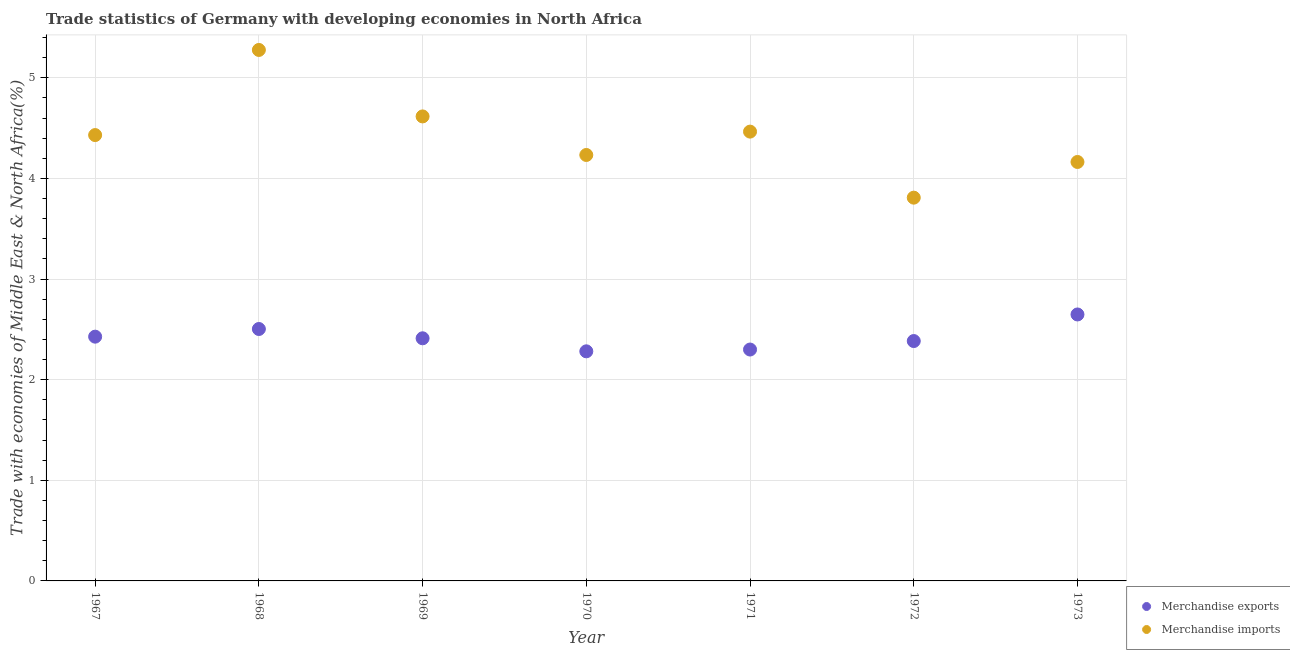Is the number of dotlines equal to the number of legend labels?
Make the answer very short. Yes. What is the merchandise imports in 1971?
Offer a terse response. 4.46. Across all years, what is the maximum merchandise exports?
Offer a very short reply. 2.65. Across all years, what is the minimum merchandise exports?
Keep it short and to the point. 2.28. In which year was the merchandise imports maximum?
Offer a very short reply. 1968. In which year was the merchandise imports minimum?
Ensure brevity in your answer.  1972. What is the total merchandise exports in the graph?
Keep it short and to the point. 16.95. What is the difference between the merchandise imports in 1968 and that in 1970?
Provide a short and direct response. 1.04. What is the difference between the merchandise exports in 1972 and the merchandise imports in 1971?
Your answer should be very brief. -2.08. What is the average merchandise exports per year?
Provide a succinct answer. 2.42. In the year 1967, what is the difference between the merchandise imports and merchandise exports?
Your answer should be very brief. 2. What is the ratio of the merchandise exports in 1968 to that in 1969?
Keep it short and to the point. 1.04. Is the difference between the merchandise imports in 1970 and 1972 greater than the difference between the merchandise exports in 1970 and 1972?
Ensure brevity in your answer.  Yes. What is the difference between the highest and the second highest merchandise imports?
Your answer should be very brief. 0.66. What is the difference between the highest and the lowest merchandise imports?
Offer a very short reply. 1.47. Does the merchandise exports monotonically increase over the years?
Keep it short and to the point. No. Is the merchandise imports strictly greater than the merchandise exports over the years?
Make the answer very short. Yes. How many dotlines are there?
Provide a succinct answer. 2. Are the values on the major ticks of Y-axis written in scientific E-notation?
Your answer should be very brief. No. Does the graph contain grids?
Your answer should be very brief. Yes. How many legend labels are there?
Provide a short and direct response. 2. How are the legend labels stacked?
Provide a succinct answer. Vertical. What is the title of the graph?
Offer a terse response. Trade statistics of Germany with developing economies in North Africa. Does "Working only" appear as one of the legend labels in the graph?
Give a very brief answer. No. What is the label or title of the Y-axis?
Your answer should be very brief. Trade with economies of Middle East & North Africa(%). What is the Trade with economies of Middle East & North Africa(%) of Merchandise exports in 1967?
Offer a terse response. 2.43. What is the Trade with economies of Middle East & North Africa(%) in Merchandise imports in 1967?
Your answer should be very brief. 4.43. What is the Trade with economies of Middle East & North Africa(%) of Merchandise exports in 1968?
Give a very brief answer. 2.5. What is the Trade with economies of Middle East & North Africa(%) of Merchandise imports in 1968?
Make the answer very short. 5.28. What is the Trade with economies of Middle East & North Africa(%) of Merchandise exports in 1969?
Ensure brevity in your answer.  2.41. What is the Trade with economies of Middle East & North Africa(%) of Merchandise imports in 1969?
Your response must be concise. 4.62. What is the Trade with economies of Middle East & North Africa(%) of Merchandise exports in 1970?
Provide a succinct answer. 2.28. What is the Trade with economies of Middle East & North Africa(%) in Merchandise imports in 1970?
Keep it short and to the point. 4.23. What is the Trade with economies of Middle East & North Africa(%) in Merchandise exports in 1971?
Offer a very short reply. 2.3. What is the Trade with economies of Middle East & North Africa(%) of Merchandise imports in 1971?
Make the answer very short. 4.46. What is the Trade with economies of Middle East & North Africa(%) in Merchandise exports in 1972?
Your answer should be compact. 2.38. What is the Trade with economies of Middle East & North Africa(%) in Merchandise imports in 1972?
Offer a terse response. 3.81. What is the Trade with economies of Middle East & North Africa(%) of Merchandise exports in 1973?
Ensure brevity in your answer.  2.65. What is the Trade with economies of Middle East & North Africa(%) of Merchandise imports in 1973?
Provide a short and direct response. 4.16. Across all years, what is the maximum Trade with economies of Middle East & North Africa(%) of Merchandise exports?
Offer a terse response. 2.65. Across all years, what is the maximum Trade with economies of Middle East & North Africa(%) of Merchandise imports?
Your response must be concise. 5.28. Across all years, what is the minimum Trade with economies of Middle East & North Africa(%) of Merchandise exports?
Give a very brief answer. 2.28. Across all years, what is the minimum Trade with economies of Middle East & North Africa(%) in Merchandise imports?
Your answer should be compact. 3.81. What is the total Trade with economies of Middle East & North Africa(%) in Merchandise exports in the graph?
Ensure brevity in your answer.  16.95. What is the total Trade with economies of Middle East & North Africa(%) of Merchandise imports in the graph?
Provide a succinct answer. 30.99. What is the difference between the Trade with economies of Middle East & North Africa(%) of Merchandise exports in 1967 and that in 1968?
Your response must be concise. -0.08. What is the difference between the Trade with economies of Middle East & North Africa(%) in Merchandise imports in 1967 and that in 1968?
Your answer should be very brief. -0.85. What is the difference between the Trade with economies of Middle East & North Africa(%) of Merchandise exports in 1967 and that in 1969?
Make the answer very short. 0.02. What is the difference between the Trade with economies of Middle East & North Africa(%) in Merchandise imports in 1967 and that in 1969?
Give a very brief answer. -0.19. What is the difference between the Trade with economies of Middle East & North Africa(%) in Merchandise exports in 1967 and that in 1970?
Give a very brief answer. 0.15. What is the difference between the Trade with economies of Middle East & North Africa(%) in Merchandise imports in 1967 and that in 1970?
Keep it short and to the point. 0.2. What is the difference between the Trade with economies of Middle East & North Africa(%) in Merchandise exports in 1967 and that in 1971?
Offer a terse response. 0.13. What is the difference between the Trade with economies of Middle East & North Africa(%) in Merchandise imports in 1967 and that in 1971?
Offer a terse response. -0.03. What is the difference between the Trade with economies of Middle East & North Africa(%) of Merchandise exports in 1967 and that in 1972?
Your response must be concise. 0.04. What is the difference between the Trade with economies of Middle East & North Africa(%) in Merchandise imports in 1967 and that in 1972?
Make the answer very short. 0.62. What is the difference between the Trade with economies of Middle East & North Africa(%) in Merchandise exports in 1967 and that in 1973?
Provide a short and direct response. -0.22. What is the difference between the Trade with economies of Middle East & North Africa(%) of Merchandise imports in 1967 and that in 1973?
Provide a succinct answer. 0.27. What is the difference between the Trade with economies of Middle East & North Africa(%) of Merchandise exports in 1968 and that in 1969?
Provide a succinct answer. 0.09. What is the difference between the Trade with economies of Middle East & North Africa(%) in Merchandise imports in 1968 and that in 1969?
Provide a succinct answer. 0.66. What is the difference between the Trade with economies of Middle East & North Africa(%) of Merchandise exports in 1968 and that in 1970?
Provide a succinct answer. 0.22. What is the difference between the Trade with economies of Middle East & North Africa(%) in Merchandise imports in 1968 and that in 1970?
Provide a short and direct response. 1.04. What is the difference between the Trade with economies of Middle East & North Africa(%) in Merchandise exports in 1968 and that in 1971?
Make the answer very short. 0.2. What is the difference between the Trade with economies of Middle East & North Africa(%) of Merchandise imports in 1968 and that in 1971?
Offer a terse response. 0.81. What is the difference between the Trade with economies of Middle East & North Africa(%) in Merchandise exports in 1968 and that in 1972?
Provide a succinct answer. 0.12. What is the difference between the Trade with economies of Middle East & North Africa(%) of Merchandise imports in 1968 and that in 1972?
Your answer should be compact. 1.47. What is the difference between the Trade with economies of Middle East & North Africa(%) of Merchandise exports in 1968 and that in 1973?
Keep it short and to the point. -0.14. What is the difference between the Trade with economies of Middle East & North Africa(%) in Merchandise imports in 1968 and that in 1973?
Ensure brevity in your answer.  1.11. What is the difference between the Trade with economies of Middle East & North Africa(%) of Merchandise exports in 1969 and that in 1970?
Keep it short and to the point. 0.13. What is the difference between the Trade with economies of Middle East & North Africa(%) in Merchandise imports in 1969 and that in 1970?
Give a very brief answer. 0.38. What is the difference between the Trade with economies of Middle East & North Africa(%) in Merchandise exports in 1969 and that in 1971?
Offer a very short reply. 0.11. What is the difference between the Trade with economies of Middle East & North Africa(%) in Merchandise imports in 1969 and that in 1971?
Provide a succinct answer. 0.15. What is the difference between the Trade with economies of Middle East & North Africa(%) of Merchandise exports in 1969 and that in 1972?
Offer a terse response. 0.03. What is the difference between the Trade with economies of Middle East & North Africa(%) of Merchandise imports in 1969 and that in 1972?
Give a very brief answer. 0.81. What is the difference between the Trade with economies of Middle East & North Africa(%) of Merchandise exports in 1969 and that in 1973?
Provide a succinct answer. -0.24. What is the difference between the Trade with economies of Middle East & North Africa(%) in Merchandise imports in 1969 and that in 1973?
Offer a very short reply. 0.45. What is the difference between the Trade with economies of Middle East & North Africa(%) in Merchandise exports in 1970 and that in 1971?
Your answer should be compact. -0.02. What is the difference between the Trade with economies of Middle East & North Africa(%) in Merchandise imports in 1970 and that in 1971?
Offer a terse response. -0.23. What is the difference between the Trade with economies of Middle East & North Africa(%) of Merchandise exports in 1970 and that in 1972?
Your answer should be very brief. -0.1. What is the difference between the Trade with economies of Middle East & North Africa(%) in Merchandise imports in 1970 and that in 1972?
Give a very brief answer. 0.42. What is the difference between the Trade with economies of Middle East & North Africa(%) in Merchandise exports in 1970 and that in 1973?
Make the answer very short. -0.37. What is the difference between the Trade with economies of Middle East & North Africa(%) of Merchandise imports in 1970 and that in 1973?
Provide a short and direct response. 0.07. What is the difference between the Trade with economies of Middle East & North Africa(%) of Merchandise exports in 1971 and that in 1972?
Offer a very short reply. -0.08. What is the difference between the Trade with economies of Middle East & North Africa(%) of Merchandise imports in 1971 and that in 1972?
Provide a short and direct response. 0.66. What is the difference between the Trade with economies of Middle East & North Africa(%) in Merchandise exports in 1971 and that in 1973?
Your answer should be very brief. -0.35. What is the difference between the Trade with economies of Middle East & North Africa(%) in Merchandise imports in 1971 and that in 1973?
Provide a short and direct response. 0.3. What is the difference between the Trade with economies of Middle East & North Africa(%) of Merchandise exports in 1972 and that in 1973?
Provide a succinct answer. -0.26. What is the difference between the Trade with economies of Middle East & North Africa(%) of Merchandise imports in 1972 and that in 1973?
Offer a very short reply. -0.35. What is the difference between the Trade with economies of Middle East & North Africa(%) in Merchandise exports in 1967 and the Trade with economies of Middle East & North Africa(%) in Merchandise imports in 1968?
Your answer should be very brief. -2.85. What is the difference between the Trade with economies of Middle East & North Africa(%) in Merchandise exports in 1967 and the Trade with economies of Middle East & North Africa(%) in Merchandise imports in 1969?
Your answer should be very brief. -2.19. What is the difference between the Trade with economies of Middle East & North Africa(%) of Merchandise exports in 1967 and the Trade with economies of Middle East & North Africa(%) of Merchandise imports in 1970?
Ensure brevity in your answer.  -1.81. What is the difference between the Trade with economies of Middle East & North Africa(%) of Merchandise exports in 1967 and the Trade with economies of Middle East & North Africa(%) of Merchandise imports in 1971?
Keep it short and to the point. -2.04. What is the difference between the Trade with economies of Middle East & North Africa(%) of Merchandise exports in 1967 and the Trade with economies of Middle East & North Africa(%) of Merchandise imports in 1972?
Your answer should be compact. -1.38. What is the difference between the Trade with economies of Middle East & North Africa(%) in Merchandise exports in 1967 and the Trade with economies of Middle East & North Africa(%) in Merchandise imports in 1973?
Your answer should be compact. -1.74. What is the difference between the Trade with economies of Middle East & North Africa(%) in Merchandise exports in 1968 and the Trade with economies of Middle East & North Africa(%) in Merchandise imports in 1969?
Offer a terse response. -2.11. What is the difference between the Trade with economies of Middle East & North Africa(%) in Merchandise exports in 1968 and the Trade with economies of Middle East & North Africa(%) in Merchandise imports in 1970?
Ensure brevity in your answer.  -1.73. What is the difference between the Trade with economies of Middle East & North Africa(%) in Merchandise exports in 1968 and the Trade with economies of Middle East & North Africa(%) in Merchandise imports in 1971?
Your response must be concise. -1.96. What is the difference between the Trade with economies of Middle East & North Africa(%) of Merchandise exports in 1968 and the Trade with economies of Middle East & North Africa(%) of Merchandise imports in 1972?
Give a very brief answer. -1.31. What is the difference between the Trade with economies of Middle East & North Africa(%) in Merchandise exports in 1968 and the Trade with economies of Middle East & North Africa(%) in Merchandise imports in 1973?
Ensure brevity in your answer.  -1.66. What is the difference between the Trade with economies of Middle East & North Africa(%) in Merchandise exports in 1969 and the Trade with economies of Middle East & North Africa(%) in Merchandise imports in 1970?
Provide a short and direct response. -1.82. What is the difference between the Trade with economies of Middle East & North Africa(%) in Merchandise exports in 1969 and the Trade with economies of Middle East & North Africa(%) in Merchandise imports in 1971?
Your answer should be very brief. -2.05. What is the difference between the Trade with economies of Middle East & North Africa(%) in Merchandise exports in 1969 and the Trade with economies of Middle East & North Africa(%) in Merchandise imports in 1972?
Keep it short and to the point. -1.4. What is the difference between the Trade with economies of Middle East & North Africa(%) in Merchandise exports in 1969 and the Trade with economies of Middle East & North Africa(%) in Merchandise imports in 1973?
Your response must be concise. -1.75. What is the difference between the Trade with economies of Middle East & North Africa(%) in Merchandise exports in 1970 and the Trade with economies of Middle East & North Africa(%) in Merchandise imports in 1971?
Your answer should be compact. -2.18. What is the difference between the Trade with economies of Middle East & North Africa(%) of Merchandise exports in 1970 and the Trade with economies of Middle East & North Africa(%) of Merchandise imports in 1972?
Your response must be concise. -1.53. What is the difference between the Trade with economies of Middle East & North Africa(%) of Merchandise exports in 1970 and the Trade with economies of Middle East & North Africa(%) of Merchandise imports in 1973?
Provide a succinct answer. -1.88. What is the difference between the Trade with economies of Middle East & North Africa(%) in Merchandise exports in 1971 and the Trade with economies of Middle East & North Africa(%) in Merchandise imports in 1972?
Offer a terse response. -1.51. What is the difference between the Trade with economies of Middle East & North Africa(%) in Merchandise exports in 1971 and the Trade with economies of Middle East & North Africa(%) in Merchandise imports in 1973?
Your answer should be very brief. -1.86. What is the difference between the Trade with economies of Middle East & North Africa(%) of Merchandise exports in 1972 and the Trade with economies of Middle East & North Africa(%) of Merchandise imports in 1973?
Keep it short and to the point. -1.78. What is the average Trade with economies of Middle East & North Africa(%) in Merchandise exports per year?
Offer a terse response. 2.42. What is the average Trade with economies of Middle East & North Africa(%) in Merchandise imports per year?
Give a very brief answer. 4.43. In the year 1967, what is the difference between the Trade with economies of Middle East & North Africa(%) of Merchandise exports and Trade with economies of Middle East & North Africa(%) of Merchandise imports?
Provide a short and direct response. -2. In the year 1968, what is the difference between the Trade with economies of Middle East & North Africa(%) of Merchandise exports and Trade with economies of Middle East & North Africa(%) of Merchandise imports?
Your response must be concise. -2.77. In the year 1969, what is the difference between the Trade with economies of Middle East & North Africa(%) in Merchandise exports and Trade with economies of Middle East & North Africa(%) in Merchandise imports?
Give a very brief answer. -2.2. In the year 1970, what is the difference between the Trade with economies of Middle East & North Africa(%) in Merchandise exports and Trade with economies of Middle East & North Africa(%) in Merchandise imports?
Provide a succinct answer. -1.95. In the year 1971, what is the difference between the Trade with economies of Middle East & North Africa(%) of Merchandise exports and Trade with economies of Middle East & North Africa(%) of Merchandise imports?
Your response must be concise. -2.17. In the year 1972, what is the difference between the Trade with economies of Middle East & North Africa(%) of Merchandise exports and Trade with economies of Middle East & North Africa(%) of Merchandise imports?
Your answer should be very brief. -1.42. In the year 1973, what is the difference between the Trade with economies of Middle East & North Africa(%) of Merchandise exports and Trade with economies of Middle East & North Africa(%) of Merchandise imports?
Provide a short and direct response. -1.52. What is the ratio of the Trade with economies of Middle East & North Africa(%) of Merchandise exports in 1967 to that in 1968?
Make the answer very short. 0.97. What is the ratio of the Trade with economies of Middle East & North Africa(%) in Merchandise imports in 1967 to that in 1968?
Your response must be concise. 0.84. What is the ratio of the Trade with economies of Middle East & North Africa(%) in Merchandise imports in 1967 to that in 1969?
Offer a terse response. 0.96. What is the ratio of the Trade with economies of Middle East & North Africa(%) of Merchandise exports in 1967 to that in 1970?
Ensure brevity in your answer.  1.06. What is the ratio of the Trade with economies of Middle East & North Africa(%) in Merchandise imports in 1967 to that in 1970?
Your response must be concise. 1.05. What is the ratio of the Trade with economies of Middle East & North Africa(%) of Merchandise exports in 1967 to that in 1971?
Your answer should be compact. 1.06. What is the ratio of the Trade with economies of Middle East & North Africa(%) in Merchandise exports in 1967 to that in 1972?
Your answer should be compact. 1.02. What is the ratio of the Trade with economies of Middle East & North Africa(%) in Merchandise imports in 1967 to that in 1972?
Make the answer very short. 1.16. What is the ratio of the Trade with economies of Middle East & North Africa(%) in Merchandise imports in 1967 to that in 1973?
Your answer should be very brief. 1.06. What is the ratio of the Trade with economies of Middle East & North Africa(%) of Merchandise exports in 1968 to that in 1969?
Give a very brief answer. 1.04. What is the ratio of the Trade with economies of Middle East & North Africa(%) in Merchandise imports in 1968 to that in 1969?
Give a very brief answer. 1.14. What is the ratio of the Trade with economies of Middle East & North Africa(%) of Merchandise exports in 1968 to that in 1970?
Offer a very short reply. 1.1. What is the ratio of the Trade with economies of Middle East & North Africa(%) of Merchandise imports in 1968 to that in 1970?
Offer a terse response. 1.25. What is the ratio of the Trade with economies of Middle East & North Africa(%) in Merchandise exports in 1968 to that in 1971?
Offer a terse response. 1.09. What is the ratio of the Trade with economies of Middle East & North Africa(%) of Merchandise imports in 1968 to that in 1971?
Provide a short and direct response. 1.18. What is the ratio of the Trade with economies of Middle East & North Africa(%) of Merchandise exports in 1968 to that in 1972?
Offer a very short reply. 1.05. What is the ratio of the Trade with economies of Middle East & North Africa(%) in Merchandise imports in 1968 to that in 1972?
Your response must be concise. 1.39. What is the ratio of the Trade with economies of Middle East & North Africa(%) in Merchandise exports in 1968 to that in 1973?
Offer a very short reply. 0.95. What is the ratio of the Trade with economies of Middle East & North Africa(%) in Merchandise imports in 1968 to that in 1973?
Offer a terse response. 1.27. What is the ratio of the Trade with economies of Middle East & North Africa(%) in Merchandise exports in 1969 to that in 1970?
Your response must be concise. 1.06. What is the ratio of the Trade with economies of Middle East & North Africa(%) in Merchandise imports in 1969 to that in 1970?
Ensure brevity in your answer.  1.09. What is the ratio of the Trade with economies of Middle East & North Africa(%) in Merchandise exports in 1969 to that in 1971?
Your answer should be very brief. 1.05. What is the ratio of the Trade with economies of Middle East & North Africa(%) in Merchandise imports in 1969 to that in 1971?
Offer a very short reply. 1.03. What is the ratio of the Trade with economies of Middle East & North Africa(%) of Merchandise exports in 1969 to that in 1972?
Your response must be concise. 1.01. What is the ratio of the Trade with economies of Middle East & North Africa(%) in Merchandise imports in 1969 to that in 1972?
Ensure brevity in your answer.  1.21. What is the ratio of the Trade with economies of Middle East & North Africa(%) in Merchandise exports in 1969 to that in 1973?
Your answer should be very brief. 0.91. What is the ratio of the Trade with economies of Middle East & North Africa(%) in Merchandise imports in 1969 to that in 1973?
Ensure brevity in your answer.  1.11. What is the ratio of the Trade with economies of Middle East & North Africa(%) of Merchandise imports in 1970 to that in 1971?
Make the answer very short. 0.95. What is the ratio of the Trade with economies of Middle East & North Africa(%) in Merchandise exports in 1970 to that in 1972?
Offer a very short reply. 0.96. What is the ratio of the Trade with economies of Middle East & North Africa(%) in Merchandise imports in 1970 to that in 1972?
Provide a succinct answer. 1.11. What is the ratio of the Trade with economies of Middle East & North Africa(%) of Merchandise exports in 1970 to that in 1973?
Offer a very short reply. 0.86. What is the ratio of the Trade with economies of Middle East & North Africa(%) in Merchandise imports in 1970 to that in 1973?
Provide a succinct answer. 1.02. What is the ratio of the Trade with economies of Middle East & North Africa(%) in Merchandise exports in 1971 to that in 1972?
Offer a terse response. 0.96. What is the ratio of the Trade with economies of Middle East & North Africa(%) of Merchandise imports in 1971 to that in 1972?
Give a very brief answer. 1.17. What is the ratio of the Trade with economies of Middle East & North Africa(%) in Merchandise exports in 1971 to that in 1973?
Your answer should be compact. 0.87. What is the ratio of the Trade with economies of Middle East & North Africa(%) in Merchandise imports in 1971 to that in 1973?
Provide a succinct answer. 1.07. What is the ratio of the Trade with economies of Middle East & North Africa(%) of Merchandise exports in 1972 to that in 1973?
Your answer should be compact. 0.9. What is the ratio of the Trade with economies of Middle East & North Africa(%) of Merchandise imports in 1972 to that in 1973?
Offer a very short reply. 0.91. What is the difference between the highest and the second highest Trade with economies of Middle East & North Africa(%) of Merchandise exports?
Provide a short and direct response. 0.14. What is the difference between the highest and the second highest Trade with economies of Middle East & North Africa(%) of Merchandise imports?
Keep it short and to the point. 0.66. What is the difference between the highest and the lowest Trade with economies of Middle East & North Africa(%) in Merchandise exports?
Provide a succinct answer. 0.37. What is the difference between the highest and the lowest Trade with economies of Middle East & North Africa(%) in Merchandise imports?
Provide a short and direct response. 1.47. 